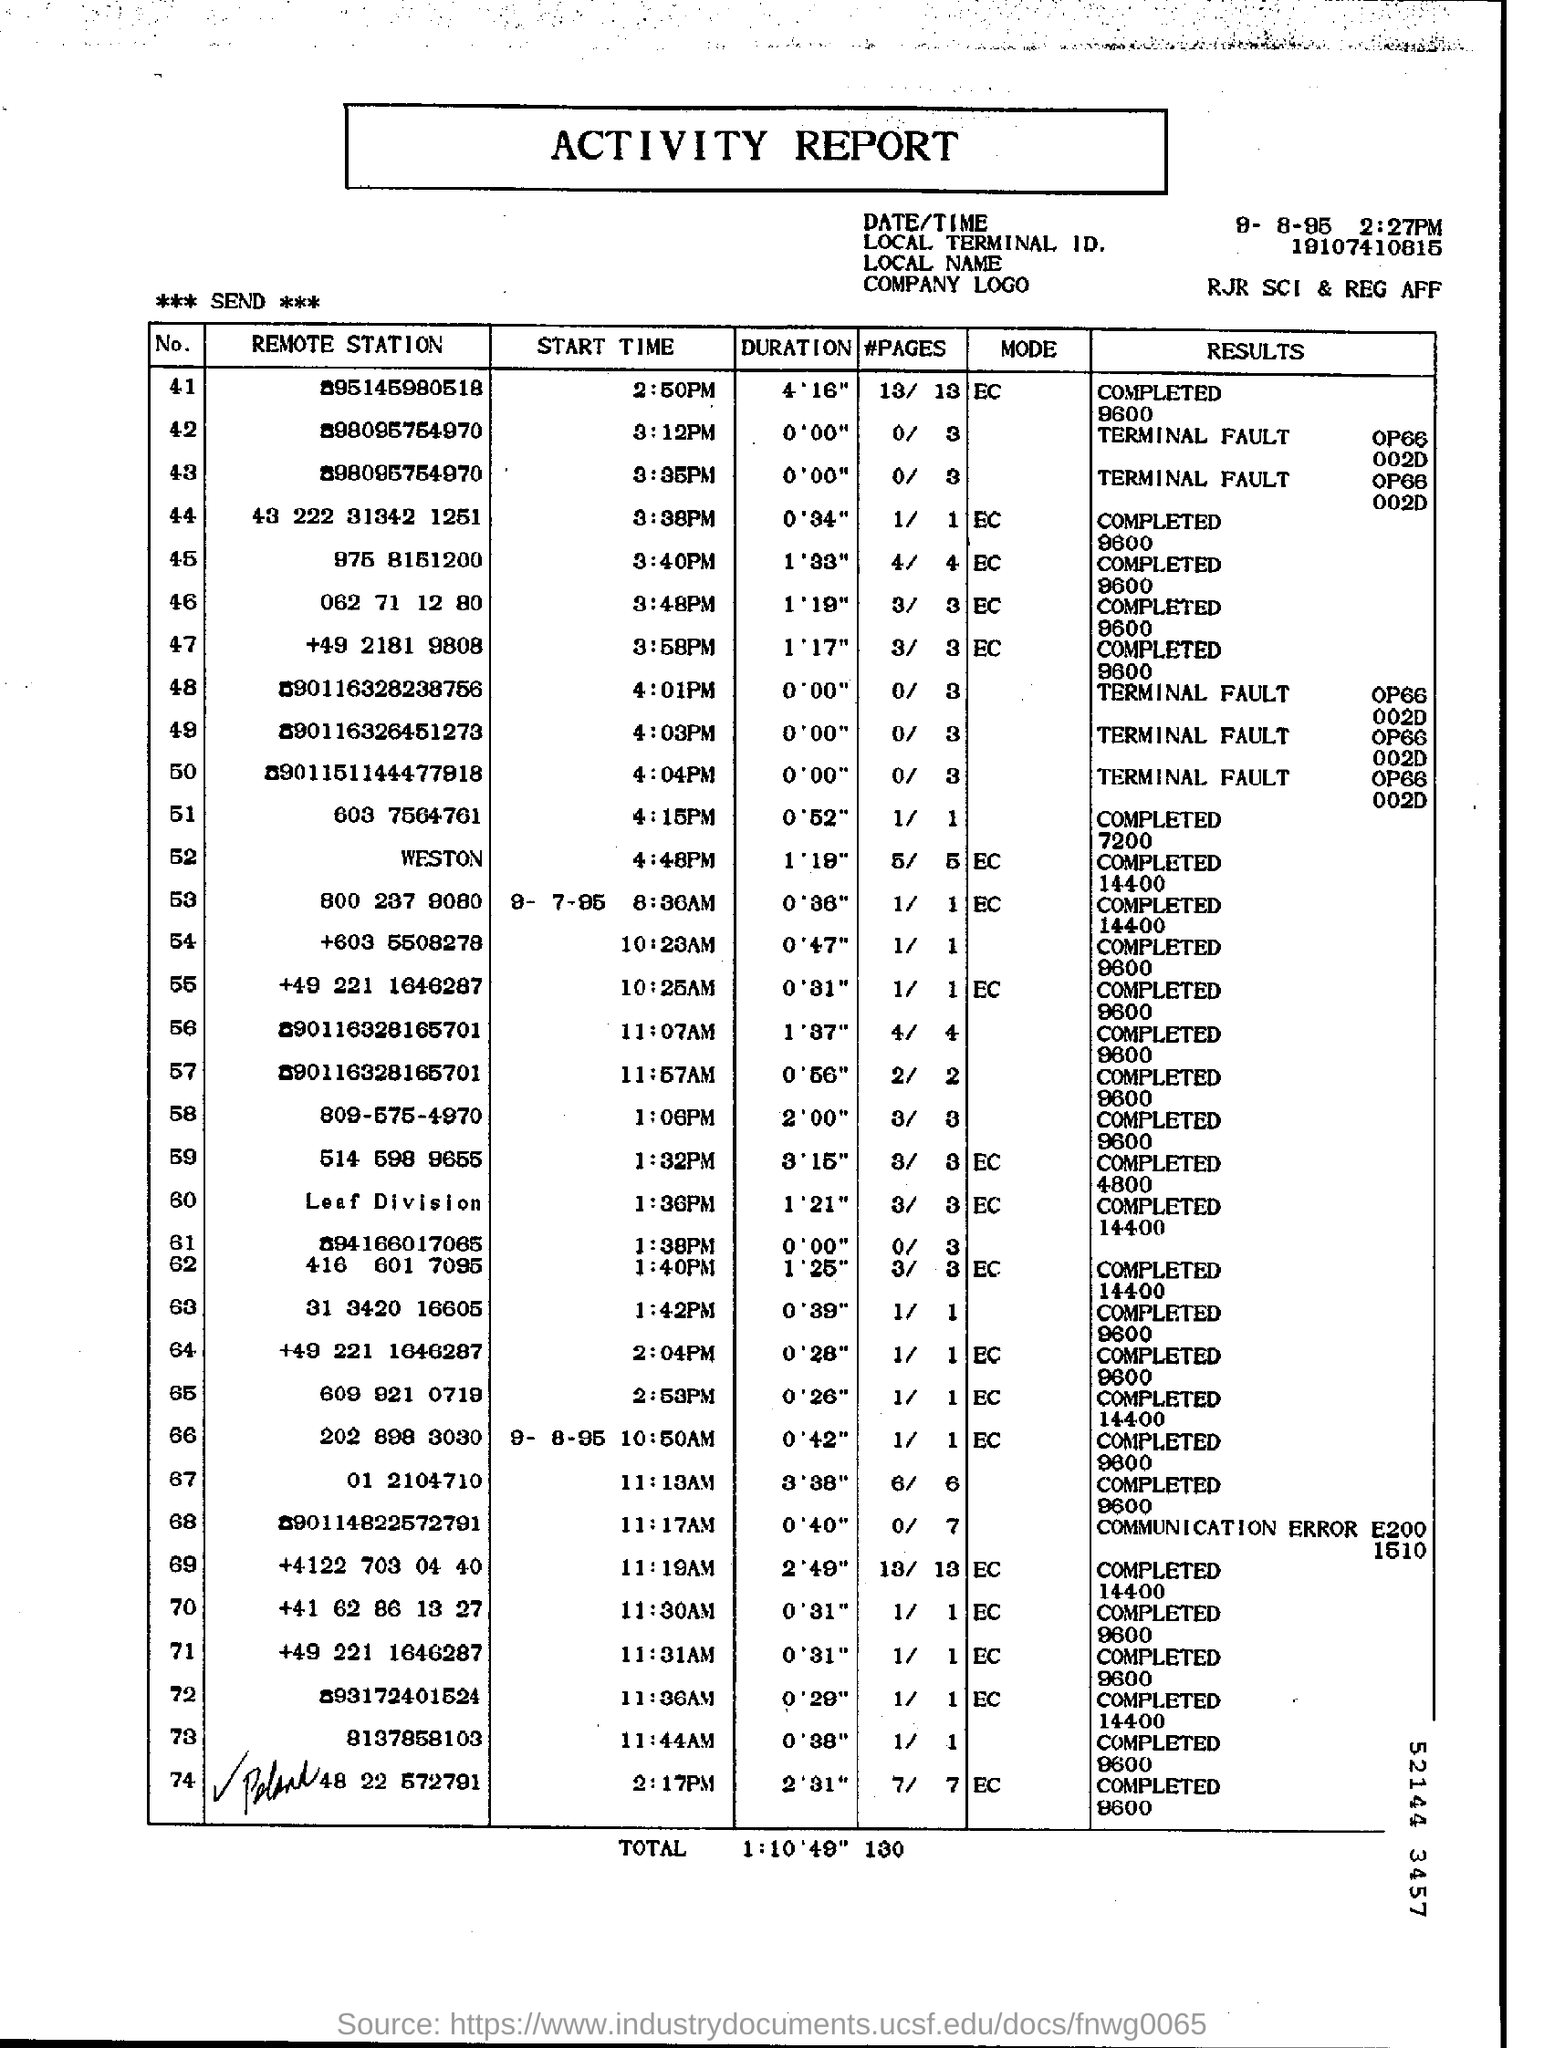What is the "DATE/TIME"?
Your answer should be very brief. 9-8-95  2:27 PM. What is the Local Terminal ID?
Offer a very short reply. 19107410815. What is the "Duration" for "Remote station" "975 8151200"?
Your response must be concise. 1'33". What is the "Start Time" for "Remote station" "975 8151200"?
Your answer should be compact. 3:40 PM. What is the "Duration" for "Remote station" "062 71 12 80"?
Ensure brevity in your answer.  1' 19". What is the "Start Time" for "Remote station" "062 71 12 80"?
Your answer should be compact. 3:48 pm. What is the "Results" for "Remote station" "062 71 12 80"?
Offer a very short reply. COMPLETED 9600. 